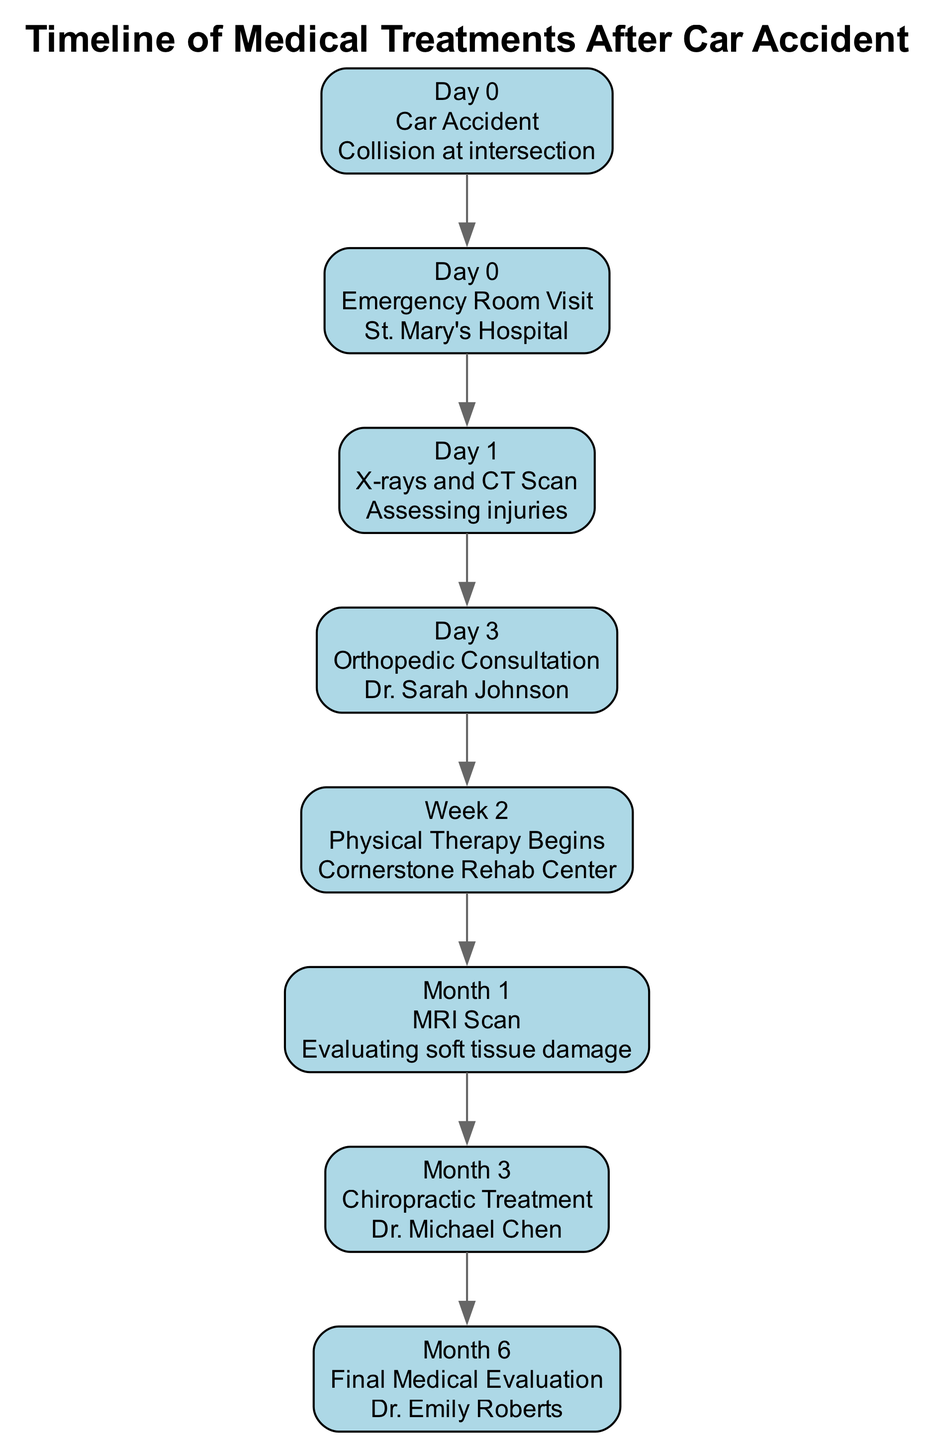What is the first event on the timeline? The timeline begins with "Car Accident" as the first event listed, occurring on Day 0.
Answer: Car Accident How many events are listed in the timeline? There are a total of 8 events shown in the timeline, starting from the accident to the final evaluation.
Answer: 8 What date does physical therapy begin? Physical therapy begins on "Week 2," which indicates the second week after the accident.
Answer: Week 2 Who conducted the final medical evaluation? The final medical evaluation is conducted by "Dr. Emily Roberts," as indicated in the timeline under Month 6.
Answer: Dr. Emily Roberts What type of scan is performed on Month 1? An "MRI Scan" is performed in Month 1 to evaluate soft tissue damage after the accident.
Answer: MRI Scan What procedure follows the orthopedic consultation? After the orthopedic consultation on Day 3, "Physical Therapy Begins" in Week 2 according to the sequence of events.
Answer: Physical Therapy Begins What is the purpose of the X-rays and CT scan? The purpose of the X-rays and CT scan, which occur on Day 1, is "Assessing injuries" sustained during the car accident.
Answer: Assessing injuries How many days after the accident did the MRI scan occur? The MRI scan occurs "Month 1" after the accident, which is approximately 30 days later, as there are about 30 days in a month.
Answer: 30 days 